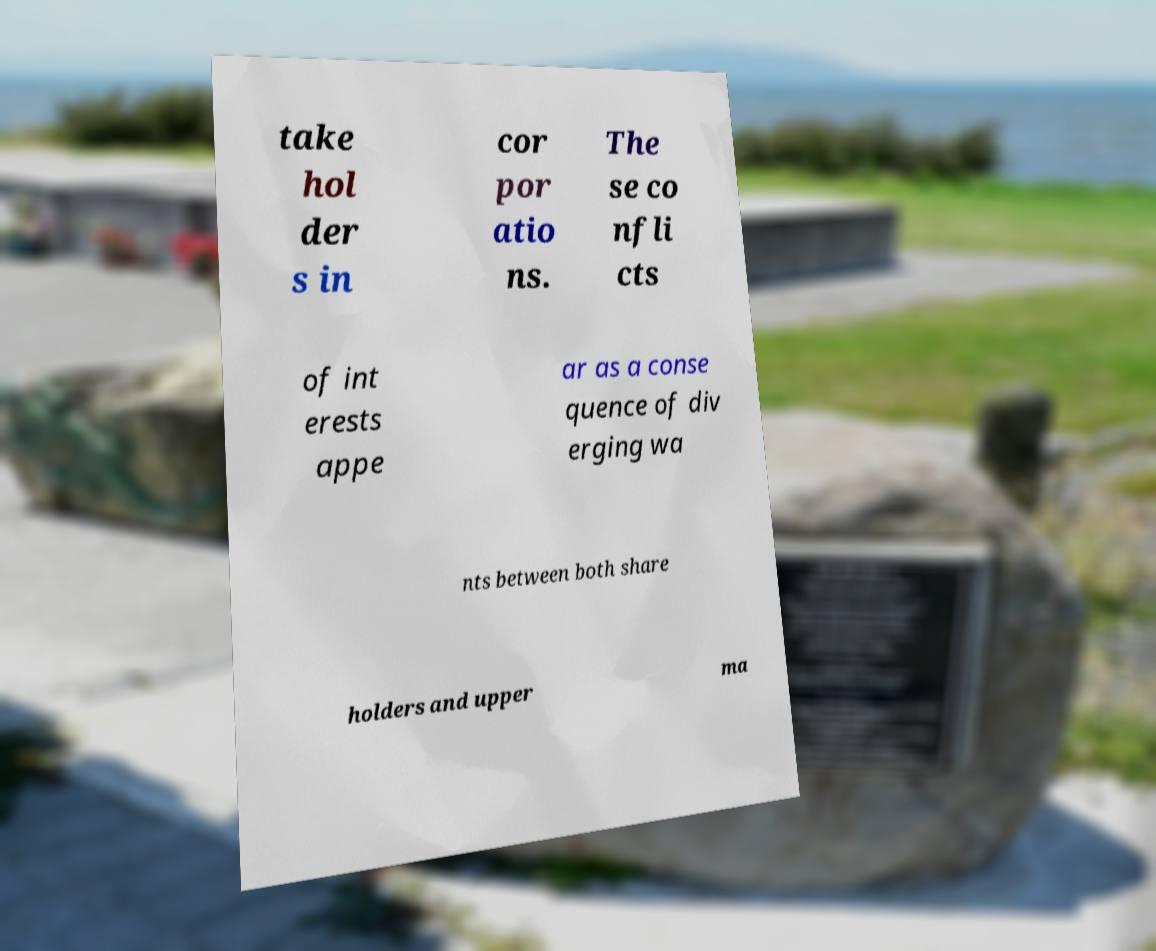What messages or text are displayed in this image? I need them in a readable, typed format. take hol der s in cor por atio ns. The se co nfli cts of int erests appe ar as a conse quence of div erging wa nts between both share holders and upper ma 